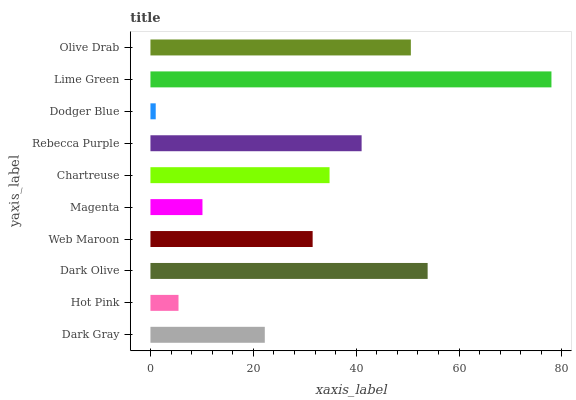Is Dodger Blue the minimum?
Answer yes or no. Yes. Is Lime Green the maximum?
Answer yes or no. Yes. Is Hot Pink the minimum?
Answer yes or no. No. Is Hot Pink the maximum?
Answer yes or no. No. Is Dark Gray greater than Hot Pink?
Answer yes or no. Yes. Is Hot Pink less than Dark Gray?
Answer yes or no. Yes. Is Hot Pink greater than Dark Gray?
Answer yes or no. No. Is Dark Gray less than Hot Pink?
Answer yes or no. No. Is Chartreuse the high median?
Answer yes or no. Yes. Is Web Maroon the low median?
Answer yes or no. Yes. Is Hot Pink the high median?
Answer yes or no. No. Is Chartreuse the low median?
Answer yes or no. No. 